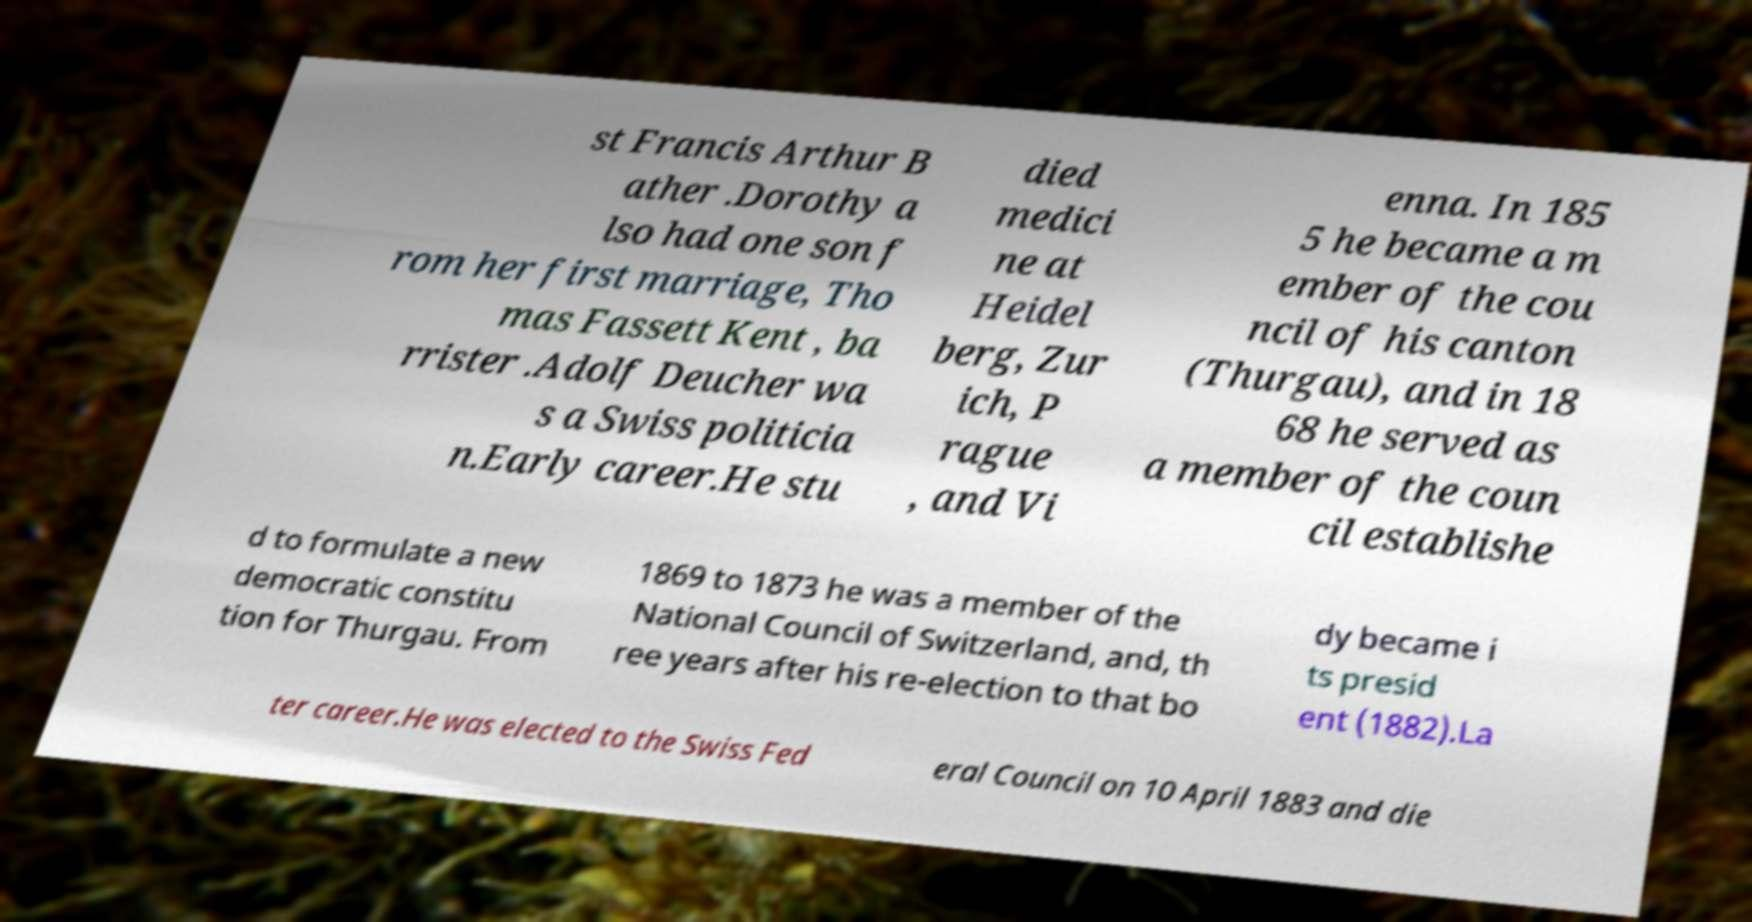I need the written content from this picture converted into text. Can you do that? st Francis Arthur B ather .Dorothy a lso had one son f rom her first marriage, Tho mas Fassett Kent , ba rrister .Adolf Deucher wa s a Swiss politicia n.Early career.He stu died medici ne at Heidel berg, Zur ich, P rague , and Vi enna. In 185 5 he became a m ember of the cou ncil of his canton (Thurgau), and in 18 68 he served as a member of the coun cil establishe d to formulate a new democratic constitu tion for Thurgau. From 1869 to 1873 he was a member of the National Council of Switzerland, and, th ree years after his re-election to that bo dy became i ts presid ent (1882).La ter career.He was elected to the Swiss Fed eral Council on 10 April 1883 and die 